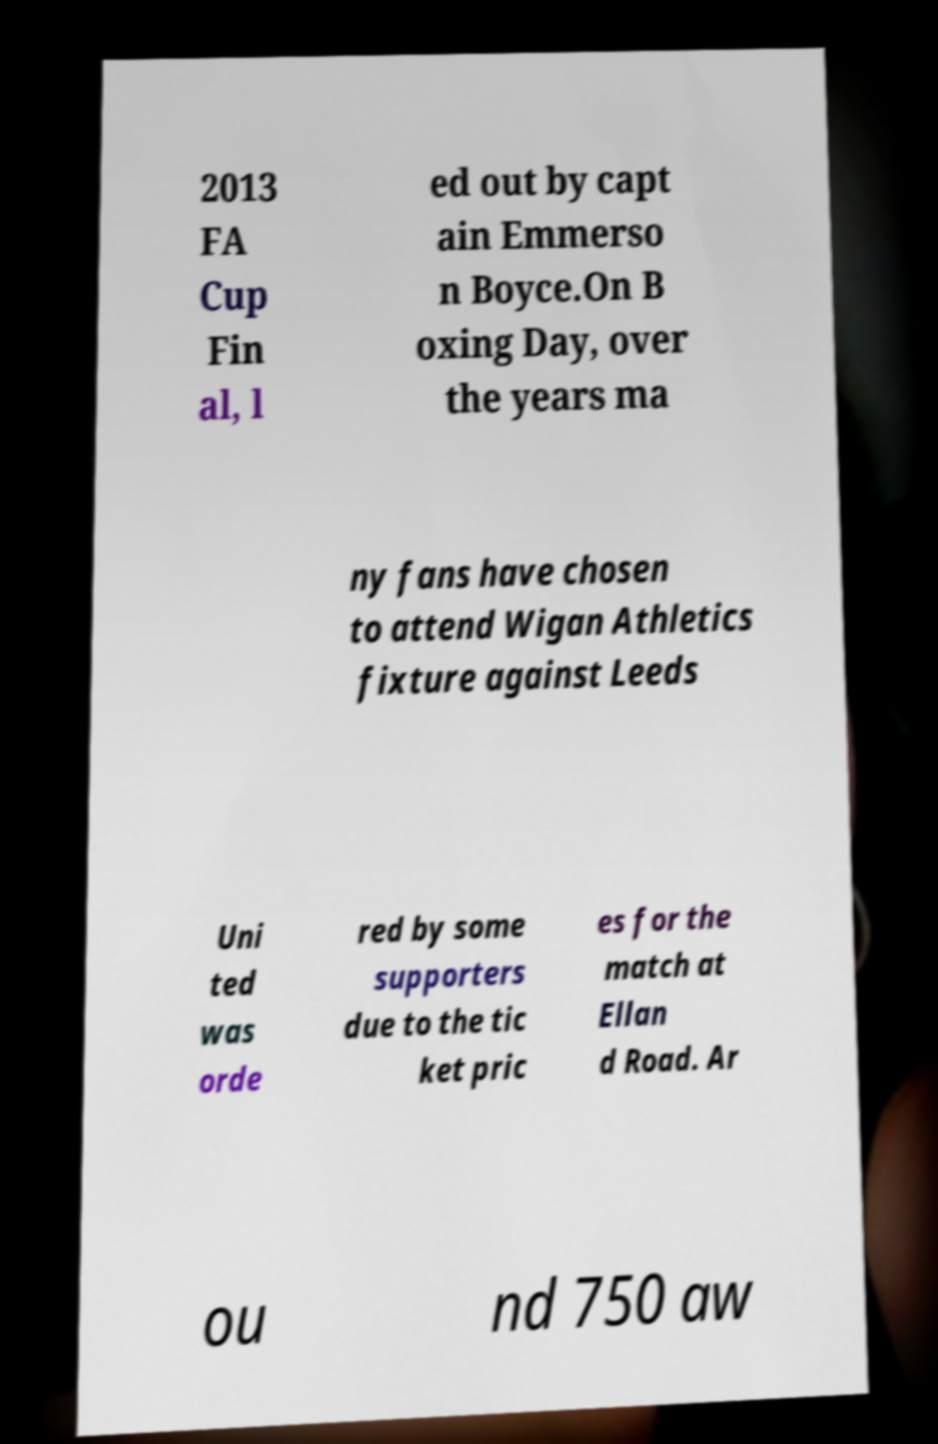Can you read and provide the text displayed in the image?This photo seems to have some interesting text. Can you extract and type it out for me? 2013 FA Cup Fin al, l ed out by capt ain Emmerso n Boyce.On B oxing Day, over the years ma ny fans have chosen to attend Wigan Athletics fixture against Leeds Uni ted was orde red by some supporters due to the tic ket pric es for the match at Ellan d Road. Ar ou nd 750 aw 